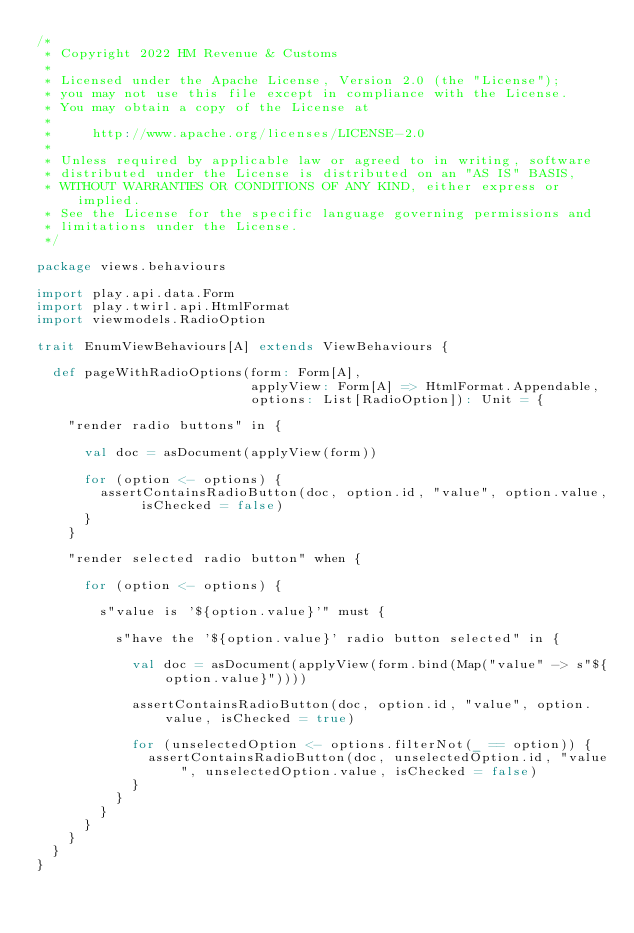Convert code to text. <code><loc_0><loc_0><loc_500><loc_500><_Scala_>/*
 * Copyright 2022 HM Revenue & Customs
 *
 * Licensed under the Apache License, Version 2.0 (the "License");
 * you may not use this file except in compliance with the License.
 * You may obtain a copy of the License at
 *
 *     http://www.apache.org/licenses/LICENSE-2.0
 *
 * Unless required by applicable law or agreed to in writing, software
 * distributed under the License is distributed on an "AS IS" BASIS,
 * WITHOUT WARRANTIES OR CONDITIONS OF ANY KIND, either express or implied.
 * See the License for the specific language governing permissions and
 * limitations under the License.
 */

package views.behaviours

import play.api.data.Form
import play.twirl.api.HtmlFormat
import viewmodels.RadioOption

trait EnumViewBehaviours[A] extends ViewBehaviours {

  def pageWithRadioOptions(form: Form[A],
                           applyView: Form[A] => HtmlFormat.Appendable,
                           options: List[RadioOption]): Unit = {

    "render radio buttons" in {

      val doc = asDocument(applyView(form))

      for (option <- options) {
        assertContainsRadioButton(doc, option.id, "value", option.value, isChecked = false)
      }
    }

    "render selected radio button" when {

      for (option <- options) {

        s"value is '${option.value}'" must {

          s"have the '${option.value}' radio button selected" in {

            val doc = asDocument(applyView(form.bind(Map("value" -> s"${option.value}"))))

            assertContainsRadioButton(doc, option.id, "value", option.value, isChecked = true)

            for (unselectedOption <- options.filterNot(_ == option)) {
              assertContainsRadioButton(doc, unselectedOption.id, "value", unselectedOption.value, isChecked = false)
            }
          }
        }
      }
    }
  }
}
</code> 